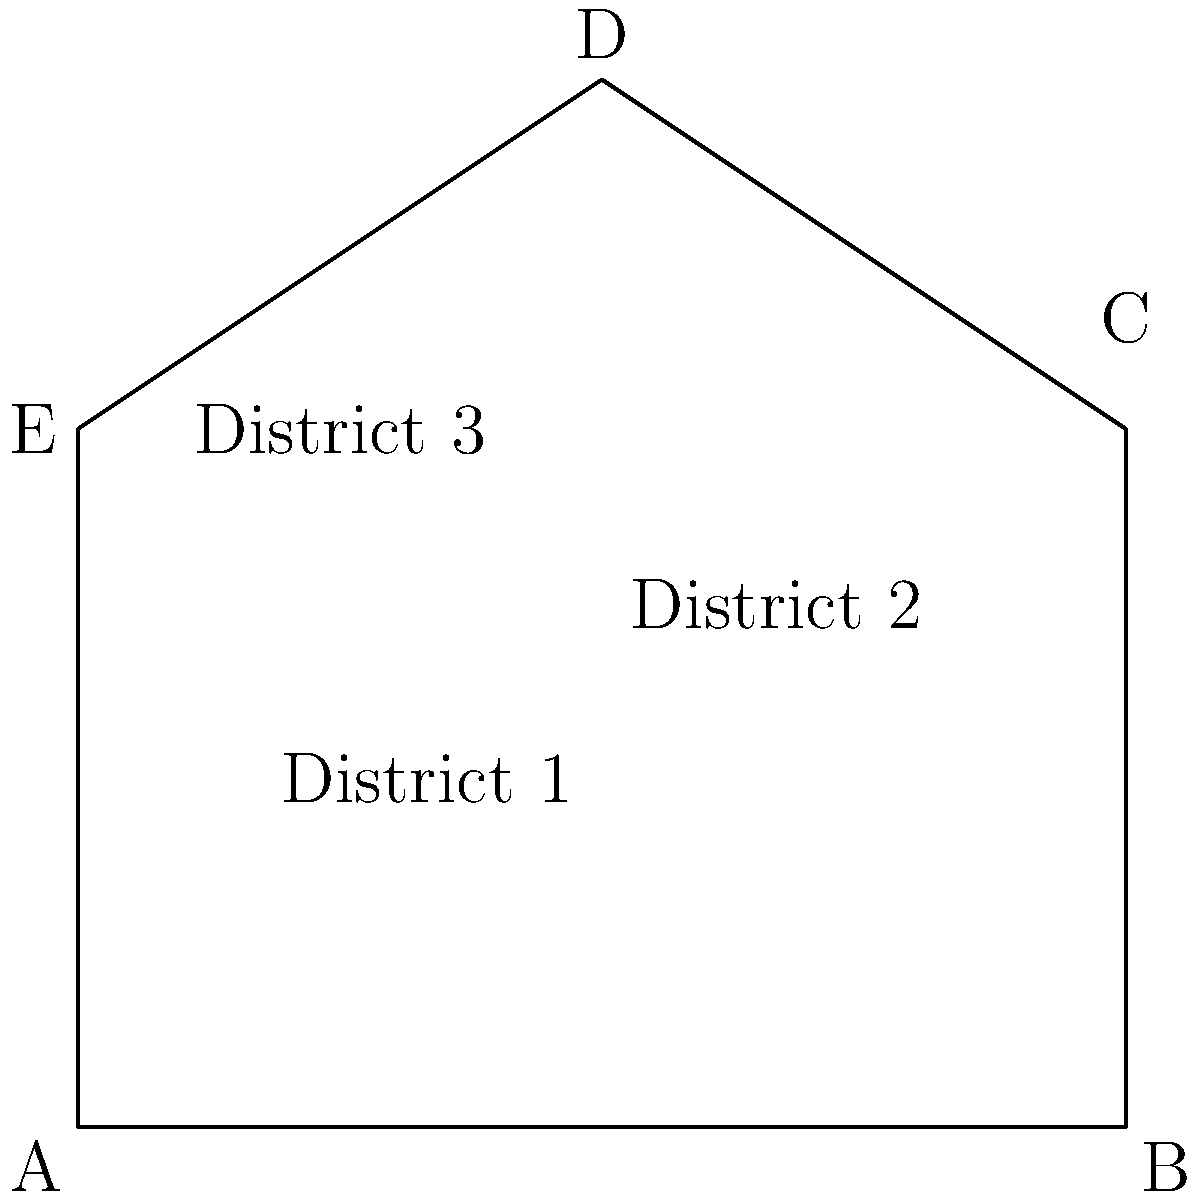A map of a city's legal jurisdictions is represented by the polygonal region ABCDE. Given that the coordinates of the vertices are A(0,0), B(6,0), C(6,4), D(3,6), and E(0,4), calculate the total area of the jurisdictions. Express your answer in square units. To find the area of the polygonal region ABCDE, we can divide it into triangles and calculate their areas:

1. Divide the polygon into three triangles: ABC, ACD, and ADE.

2. Calculate the area of triangle ABC:
   Area$_{ABC} = \frac{1}{2} \cdot 6 \cdot 4 = 12$ square units

3. Calculate the area of triangle ACD:
   Area$_{ACD} = \frac{1}{2} \cdot 6 \cdot 6 = 18$ square units

4. Calculate the area of triangle ADE:
   Area$_{ADE} = \frac{1}{2} \cdot 3 \cdot 4 = 6$ square units

5. Sum up the areas of all triangles:
   Total Area = Area$_{ABC}$ + Area$_{ACD}$ + Area$_{ADE}$
               = $12 + 18 + 6 = 36$ square units

Therefore, the total area of the jurisdictions is 36 square units.
Answer: 36 square units 